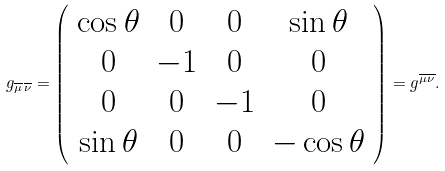Convert formula to latex. <formula><loc_0><loc_0><loc_500><loc_500>g _ { \overline { \mu } \, \overline { \nu } } = \left ( \begin{array} { c c c c } { \cos \theta } & { 0 } & { 0 } & { \sin \theta } \\ { 0 } & { - 1 } & { 0 } & { 0 } \\ { 0 } & { 0 } & { - 1 } & { 0 } \\ { \sin \theta } & { 0 } & { 0 } & { - \cos \theta } \end{array} \right ) = g ^ { \overline { \mu \nu } } .</formula> 